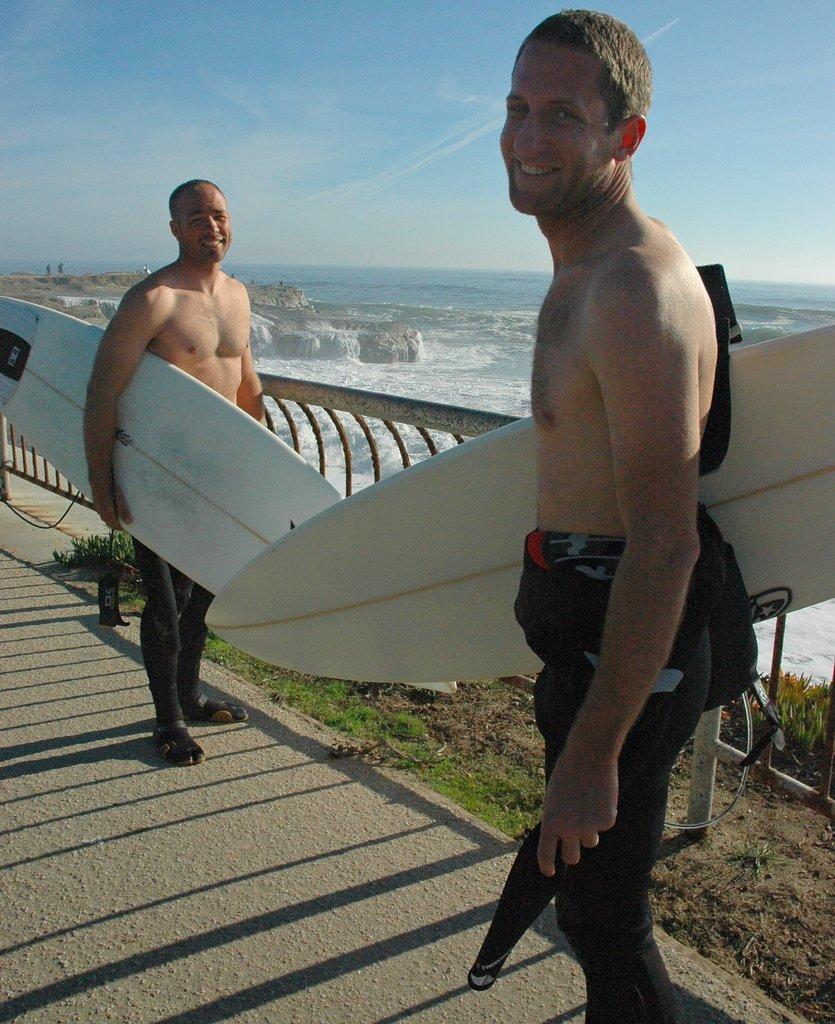In one or two sentences, can you explain what this image depicts? These two persons standing and holding surfboard. On the background we can see water,sky. This is grass. This is plant. 